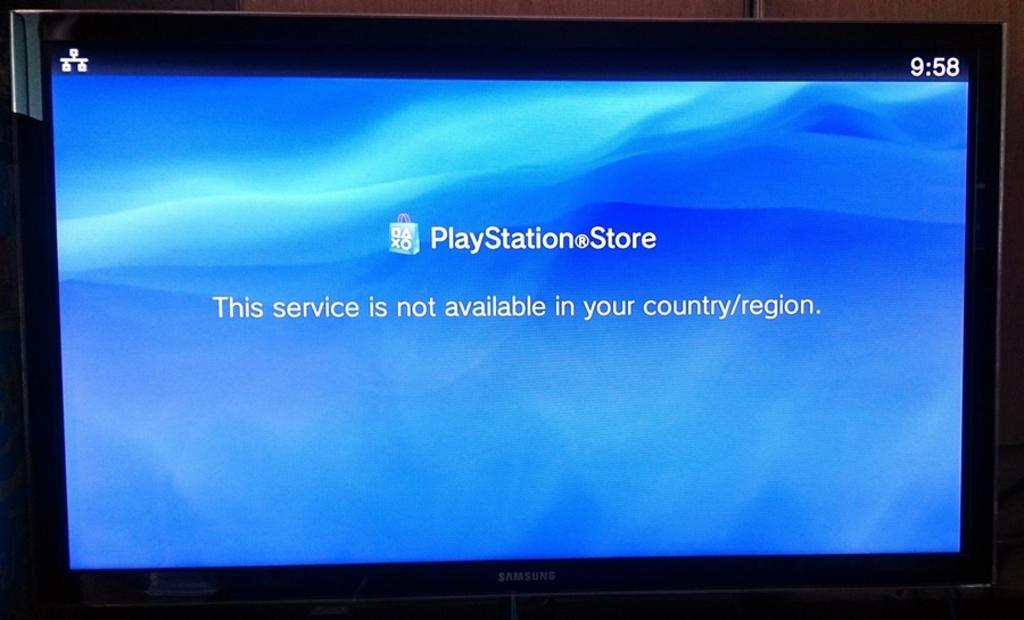<image>
Present a compact description of the photo's key features. a PlayStation store icon with a blue background 